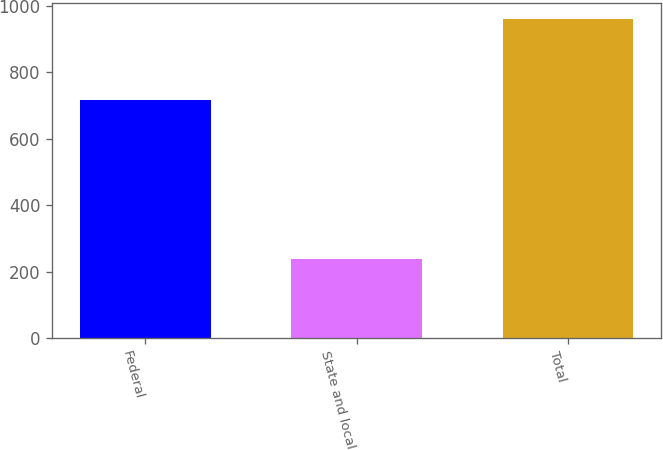Convert chart. <chart><loc_0><loc_0><loc_500><loc_500><bar_chart><fcel>Federal<fcel>State and local<fcel>Total<nl><fcel>717<fcel>239<fcel>962<nl></chart> 